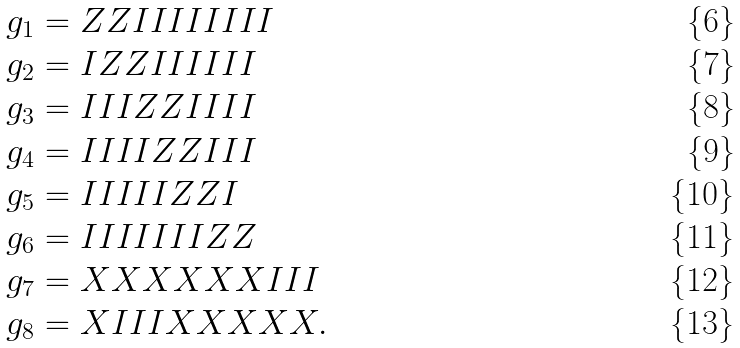<formula> <loc_0><loc_0><loc_500><loc_500>g _ { 1 } & = Z Z I I I I I I I I \\ g _ { 2 } & = I Z Z I I I I I I \\ g _ { 3 } & = I I I Z Z I I I I \\ g _ { 4 } & = I I I I Z Z I I I \\ g _ { 5 } & = I I I I I Z Z I \\ g _ { 6 } & = I I I I I I I Z Z \\ g _ { 7 } & = X X X X X X I I I \\ g _ { 8 } & = X I I I X X X X X .</formula> 